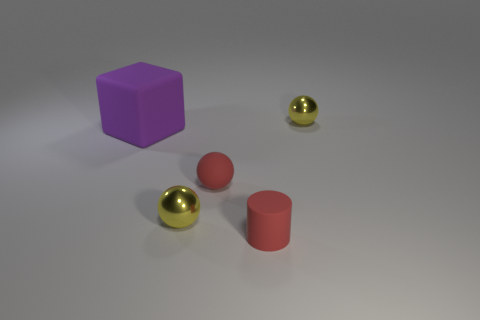Is there anything else that has the same shape as the large purple thing? Upon closer inspection of the image, it appears that no other objects share the exact same cube shape and size as the large purple object. 